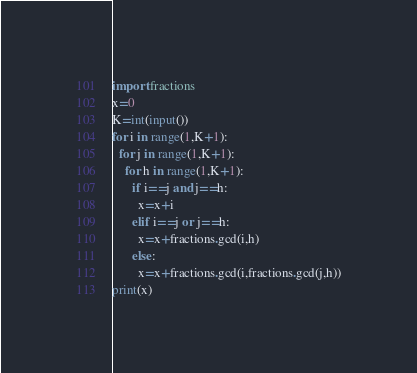Convert code to text. <code><loc_0><loc_0><loc_500><loc_500><_Python_>import fractions
x=0
K=int(input())
for i in range(1,K+1):
  for j in range(1,K+1):
    for h in range(1,K+1):
      if i==j and j==h:
        x=x+i
      elif i==j or j==h:
        x=x+fractions.gcd(i,h)
      else:
        x=x+fractions.gcd(i,fractions.gcd(j,h))
print(x)</code> 